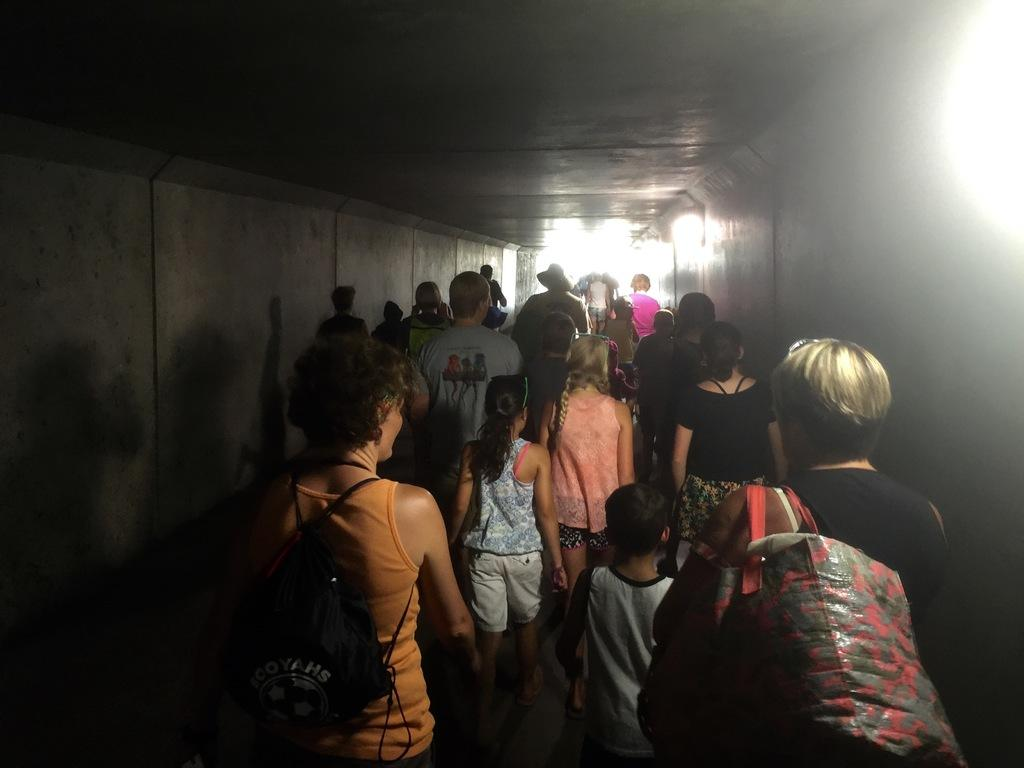How many people are in the image? There are a few people in the image. What can be seen under the people's feet in the image? The ground is visible in the image. What type of structure is present in the image? There is a wall and a roof visible in the image. Where is the light coming from in the image? There is some light on the right side of the image. What type of linen is being used to cover the bone in the image? There is no linen or bone present in the image. 